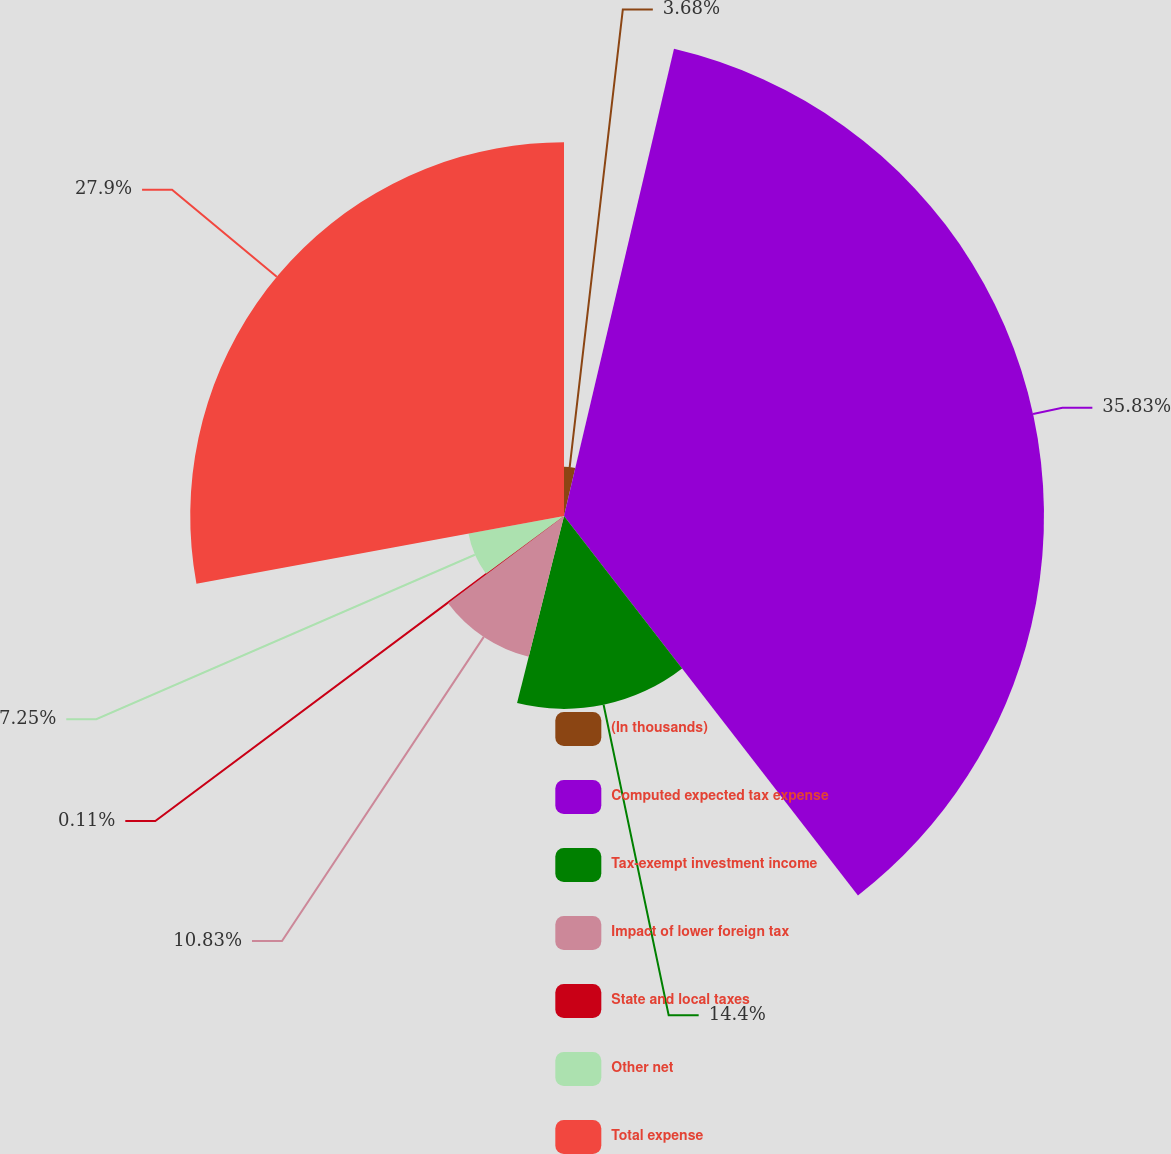<chart> <loc_0><loc_0><loc_500><loc_500><pie_chart><fcel>(In thousands)<fcel>Computed expected tax expense<fcel>Tax-exempt investment income<fcel>Impact of lower foreign tax<fcel>State and local taxes<fcel>Other net<fcel>Total expense<nl><fcel>3.68%<fcel>35.83%<fcel>14.4%<fcel>10.83%<fcel>0.11%<fcel>7.25%<fcel>27.9%<nl></chart> 